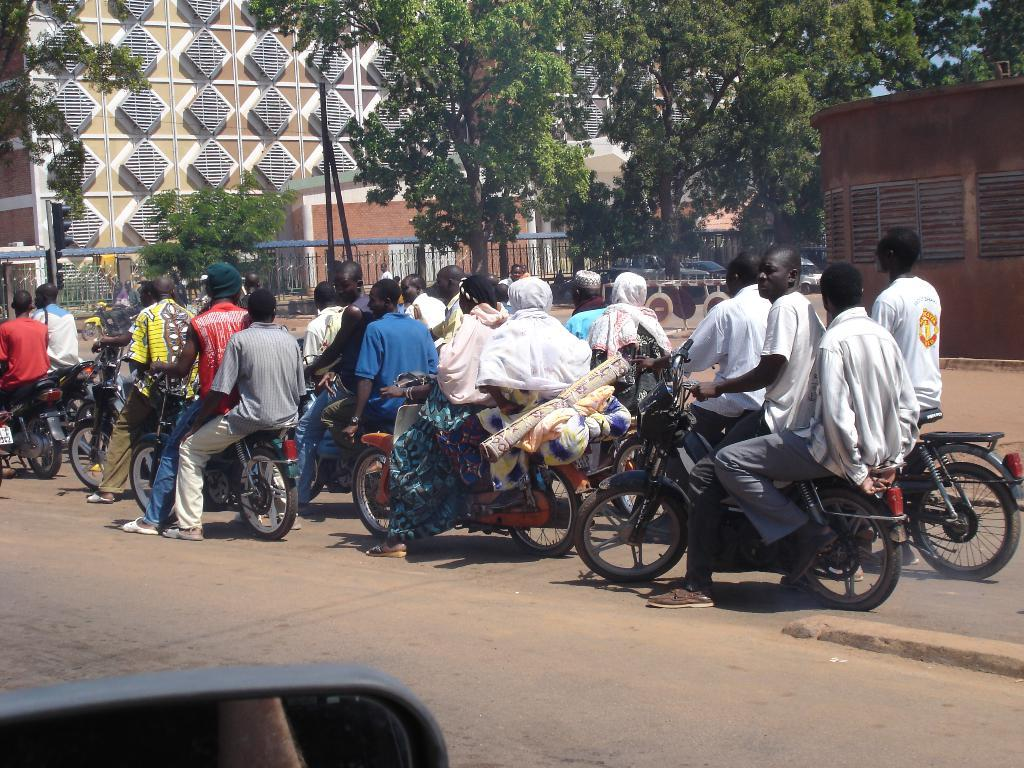What are the people in the image doing? There are persons on bikes in the image. What is the setting in which the people are riding their bikes? There is a road in the image. What can be seen in the background of the image? There is a building and trees in the background of the image. What adjustment is being made to the chin of the person on the bike in the image? There is no chin adjustment being made in the image; the persons on bikes are simply riding their bikes. What color are the eyes of the person on the bike in the image? There is no person's eyes visible in the image, as their faces are not shown. 